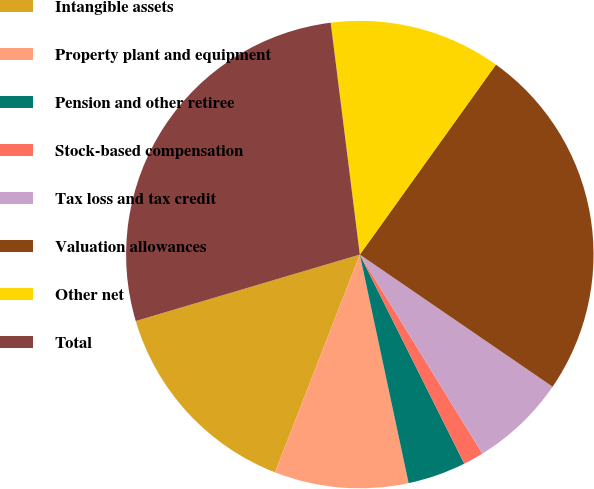Convert chart to OTSL. <chart><loc_0><loc_0><loc_500><loc_500><pie_chart><fcel>Intangible assets<fcel>Property plant and equipment<fcel>Pension and other retiree<fcel>Stock-based compensation<fcel>Tax loss and tax credit<fcel>Valuation allowances<fcel>Other net<fcel>Total<nl><fcel>14.5%<fcel>9.26%<fcel>4.03%<fcel>1.41%<fcel>6.65%<fcel>24.67%<fcel>11.88%<fcel>27.6%<nl></chart> 